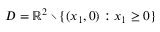Convert formula to latex. <formula><loc_0><loc_0><loc_500><loc_500>D = \mathbb { R } ^ { 2 } \ \{ ( x _ { 1 } , 0 ) \colon x _ { 1 } \geq 0 \}</formula> 